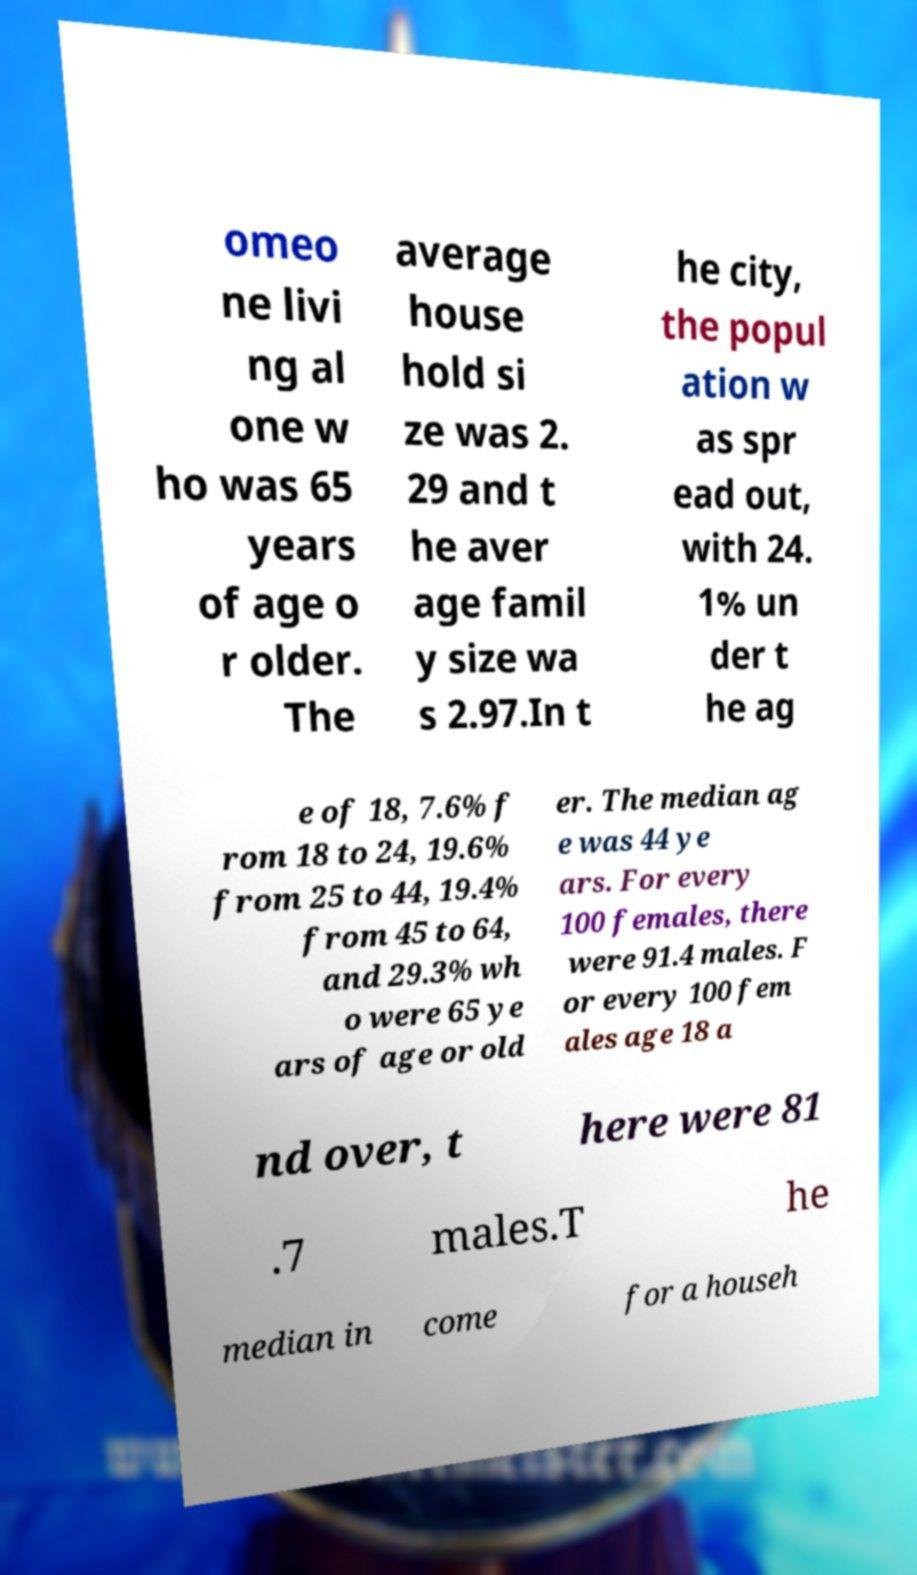Could you assist in decoding the text presented in this image and type it out clearly? omeo ne livi ng al one w ho was 65 years of age o r older. The average house hold si ze was 2. 29 and t he aver age famil y size wa s 2.97.In t he city, the popul ation w as spr ead out, with 24. 1% un der t he ag e of 18, 7.6% f rom 18 to 24, 19.6% from 25 to 44, 19.4% from 45 to 64, and 29.3% wh o were 65 ye ars of age or old er. The median ag e was 44 ye ars. For every 100 females, there were 91.4 males. F or every 100 fem ales age 18 a nd over, t here were 81 .7 males.T he median in come for a househ 